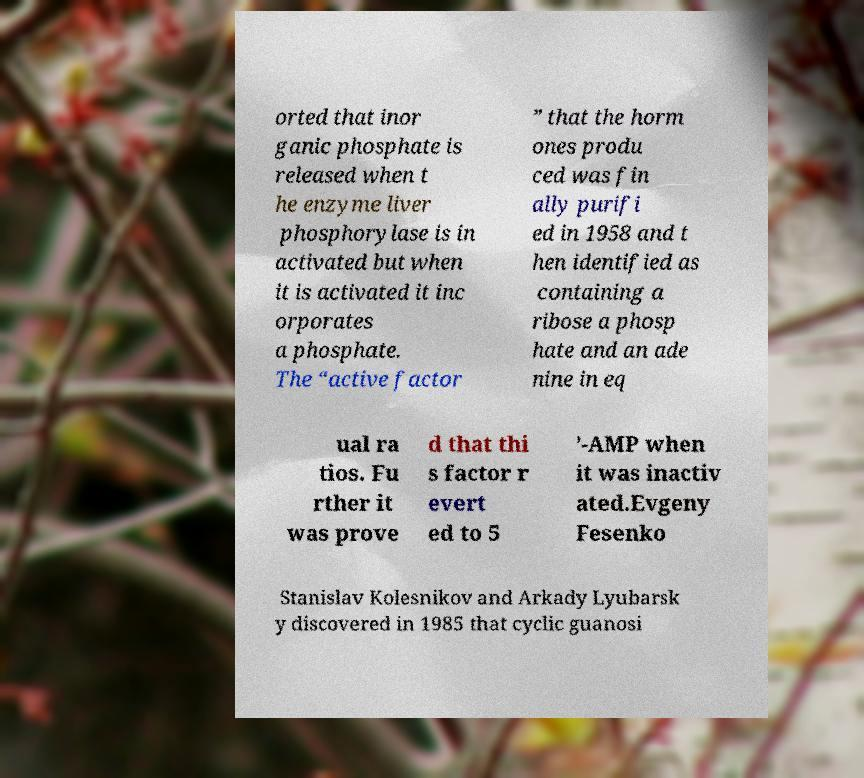Could you assist in decoding the text presented in this image and type it out clearly? orted that inor ganic phosphate is released when t he enzyme liver phosphorylase is in activated but when it is activated it inc orporates a phosphate. The “active factor ” that the horm ones produ ced was fin ally purifi ed in 1958 and t hen identified as containing a ribose a phosp hate and an ade nine in eq ual ra tios. Fu rther it was prove d that thi s factor r evert ed to 5 ’-AMP when it was inactiv ated.Evgeny Fesenko Stanislav Kolesnikov and Arkady Lyubarsk y discovered in 1985 that cyclic guanosi 